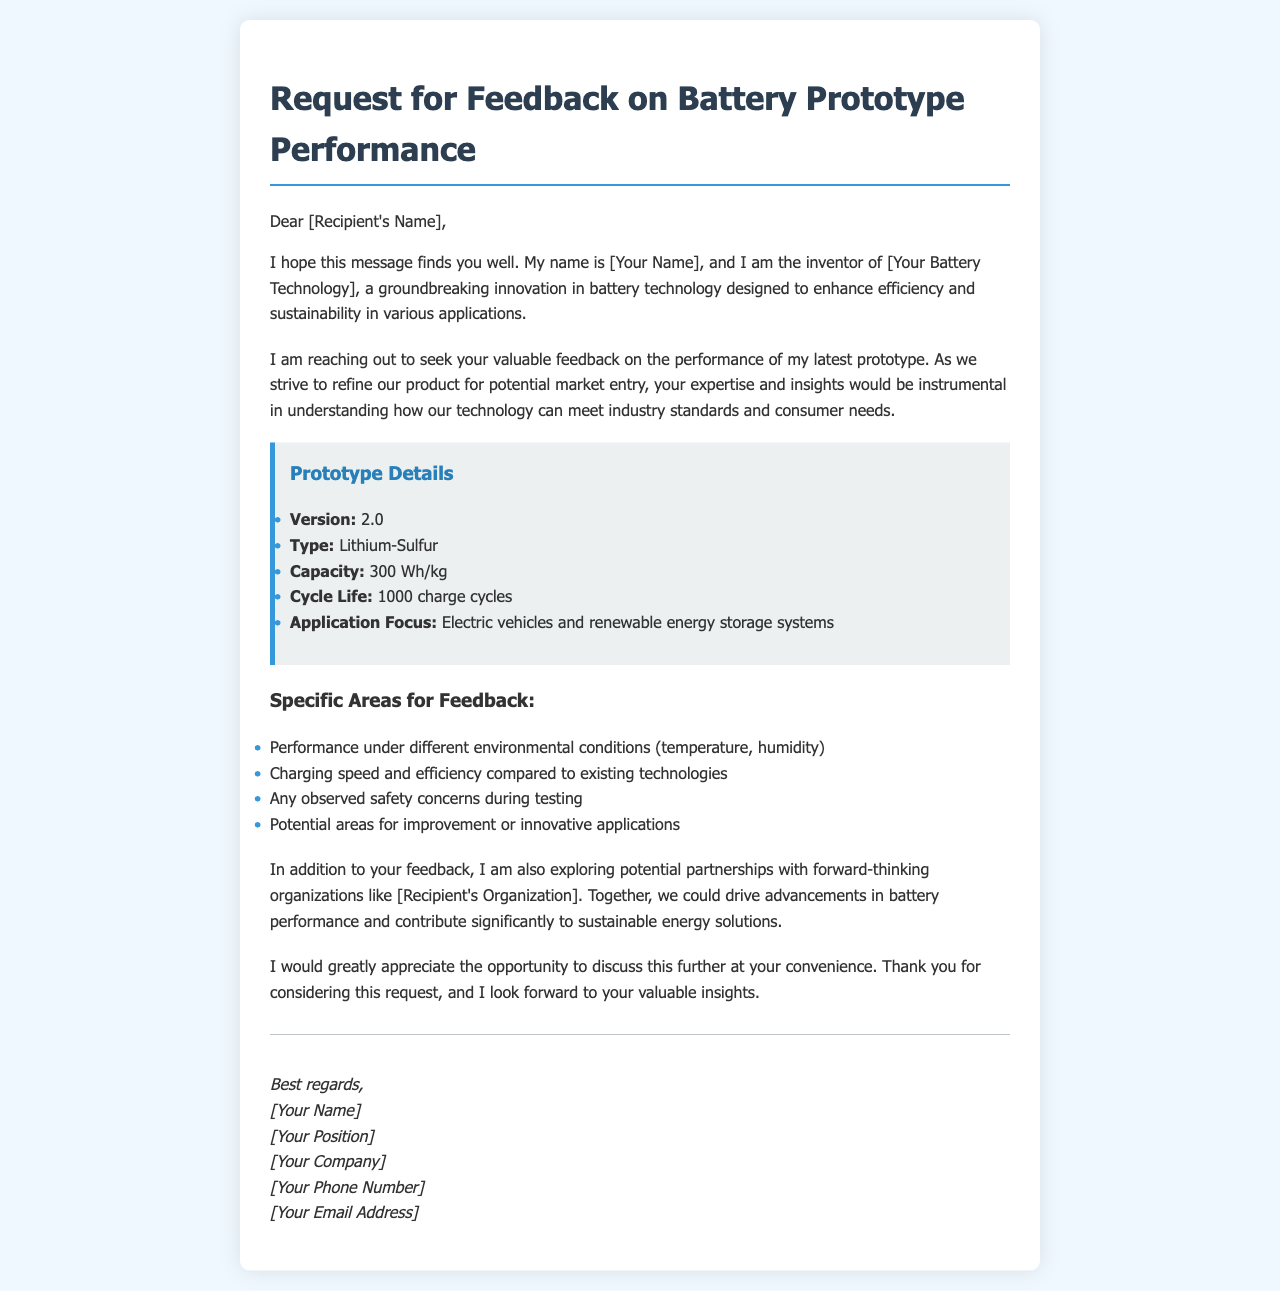What is the version of the prototype? The document specifies that the version of the prototype is indicated in the "Prototype Details" section.
Answer: 2.0 What type of battery is mentioned? The document lists the type of battery in the "Prototype Details" section as Lithium-Sulfur.
Answer: Lithium-Sulfur What is the capacity of the battery? The "Prototype Details" section provides the capacity of the battery, which is a key specification.
Answer: 300 Wh/kg How many charge cycles is the cycle life? The cycle life is stated in the "Prototype Details" section, representing how many times the battery can be charged and discharged.
Answer: 1000 charge cycles What environmental conditions should be tested for feedback? The document outlines specific areas for feedback, including environmental factors in the first bullet point.
Answer: Temperature, humidity What potential applications are mentioned for the battery? The document specifies the application focus of the battery, indicating its intended use cases.
Answer: Electric vehicles and renewable energy storage systems Who is the sender of the email? The document format includes a signature section at the end that indicates the sender's name goes here.
Answer: [Your Name] What type of organizations is the sender seeking partnerships with? The document mentions the type of organizations in the section discussing partnerships and collaboration.
Answer: Forward-thinking organizations 